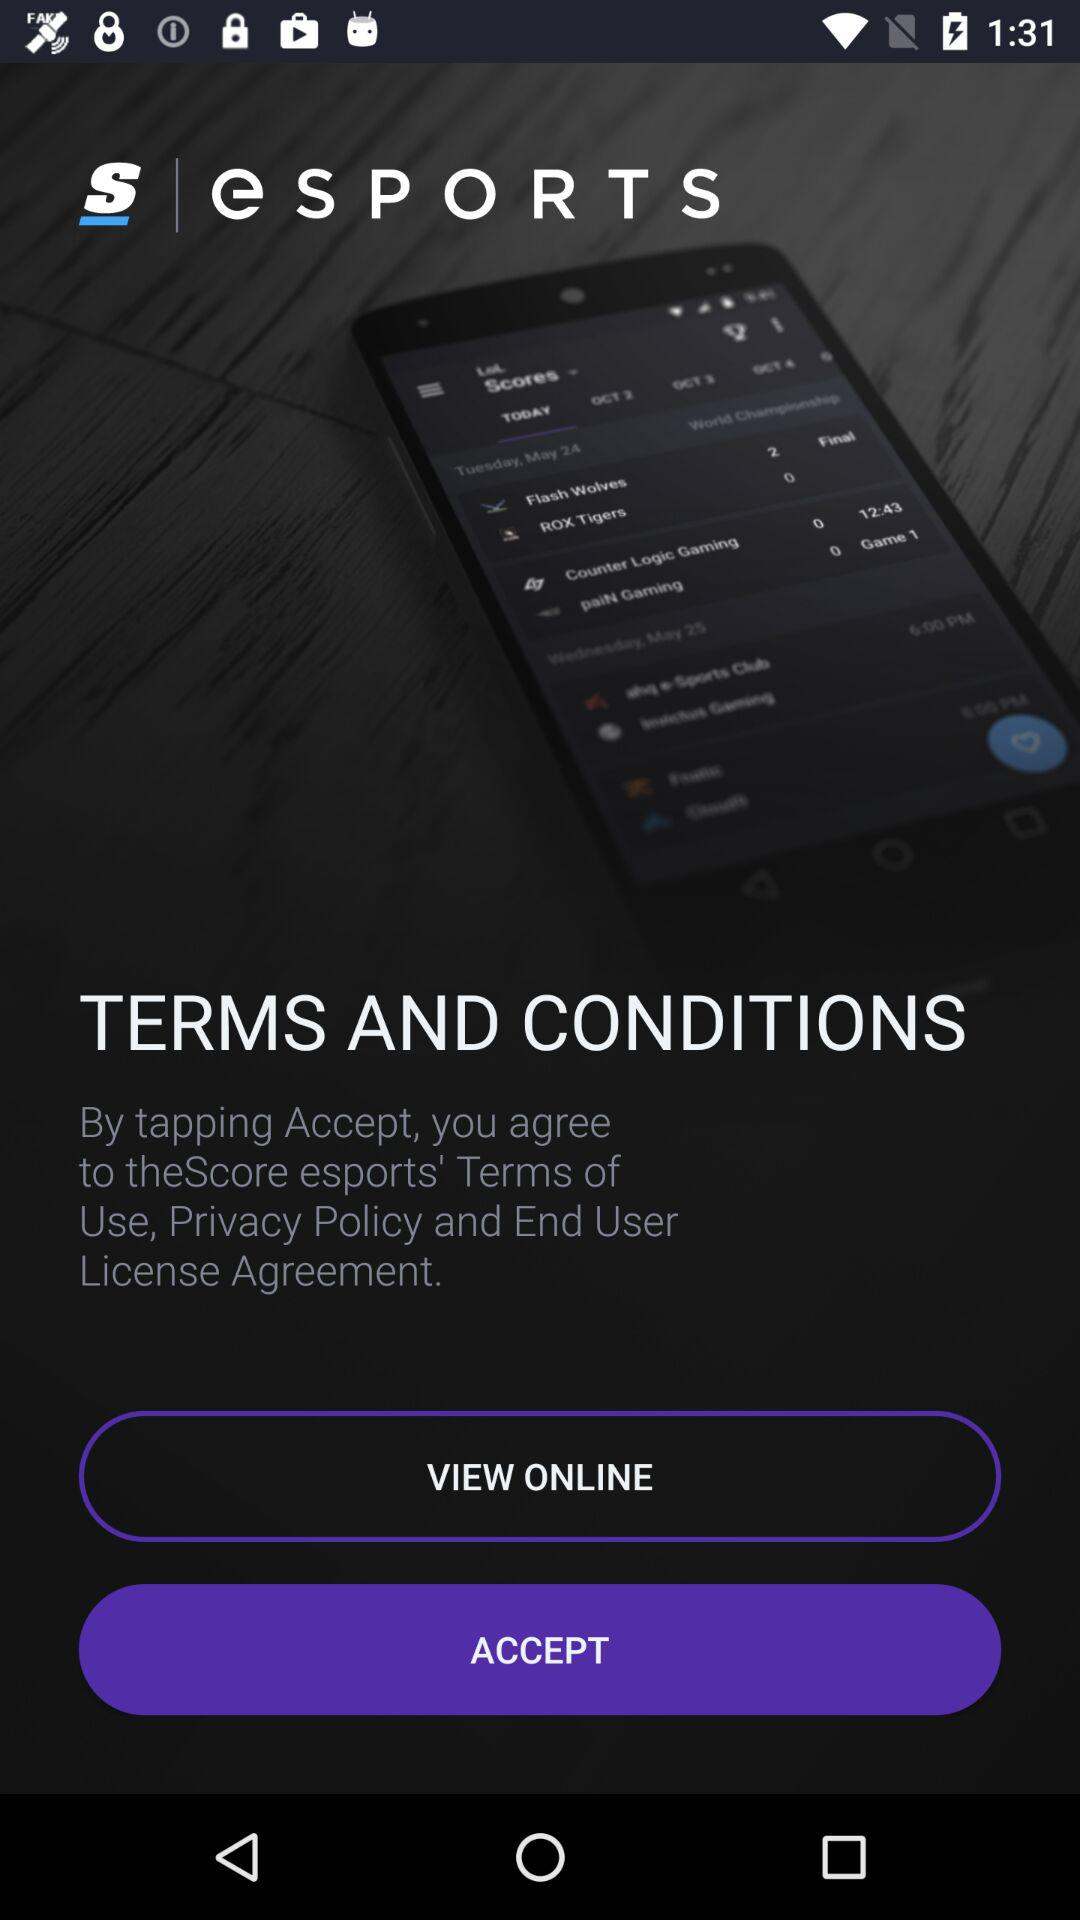What is the app name? The app name is "E S P O R T S". 